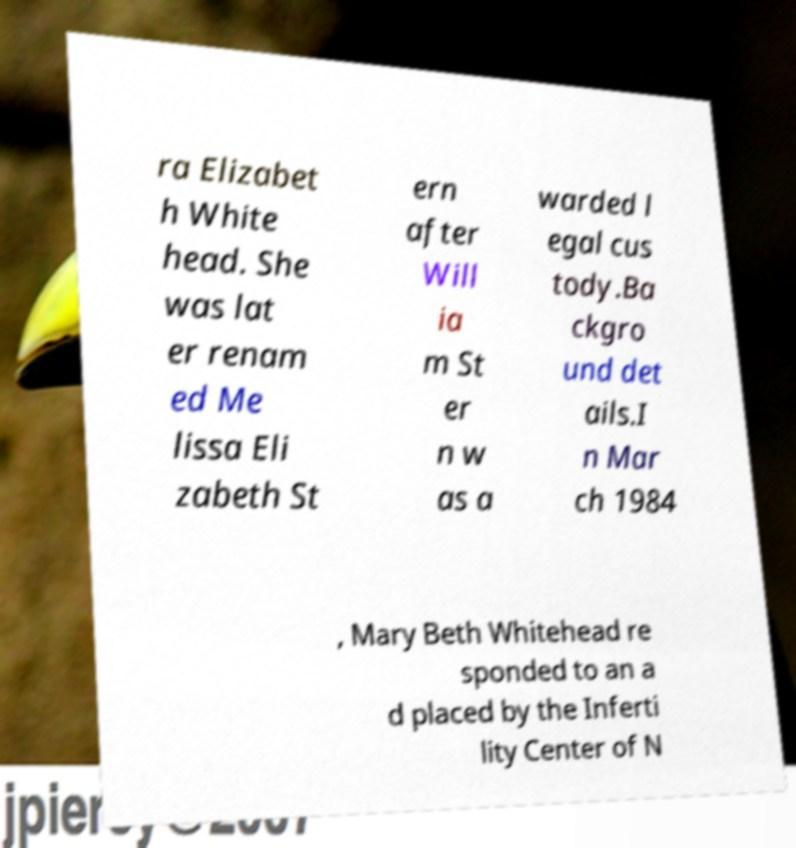What messages or text are displayed in this image? I need them in a readable, typed format. ra Elizabet h White head. She was lat er renam ed Me lissa Eli zabeth St ern after Will ia m St er n w as a warded l egal cus tody.Ba ckgro und det ails.I n Mar ch 1984 , Mary Beth Whitehead re sponded to an a d placed by the Inferti lity Center of N 